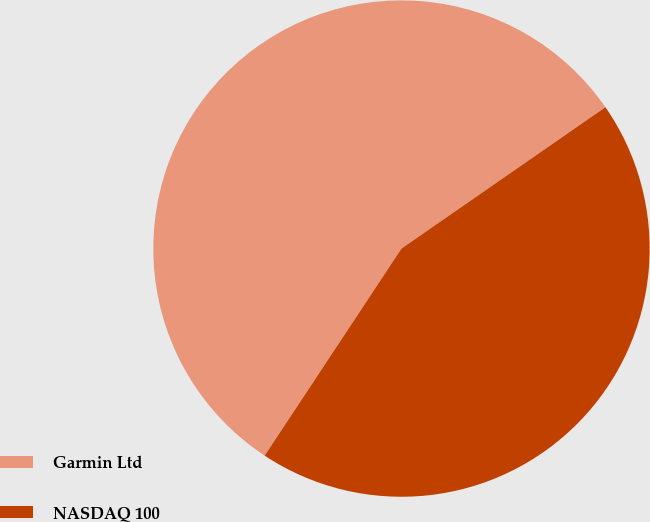Convert chart. <chart><loc_0><loc_0><loc_500><loc_500><pie_chart><fcel>Garmin Ltd<fcel>NASDAQ 100<nl><fcel>56.06%<fcel>43.94%<nl></chart> 